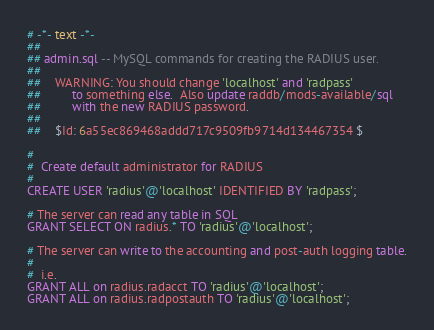Convert code to text. <code><loc_0><loc_0><loc_500><loc_500><_SQL_># -*- text -*-
##
## admin.sql -- MySQL commands for creating the RADIUS user.
##
##	WARNING: You should change 'localhost' and 'radpass'
##		 to something else.  Also update raddb/mods-available/sql
##		 with the new RADIUS password.
##
##	$Id: 6a55ec869468addd717c9509fb9714d134467354 $

#
#  Create default administrator for RADIUS
#
CREATE USER 'radius'@'localhost' IDENTIFIED BY 'radpass';

# The server can read any table in SQL
GRANT SELECT ON radius.* TO 'radius'@'localhost';

# The server can write to the accounting and post-auth logging table.
#
#  i.e.
GRANT ALL on radius.radacct TO 'radius'@'localhost';
GRANT ALL on radius.radpostauth TO 'radius'@'localhost';
</code> 